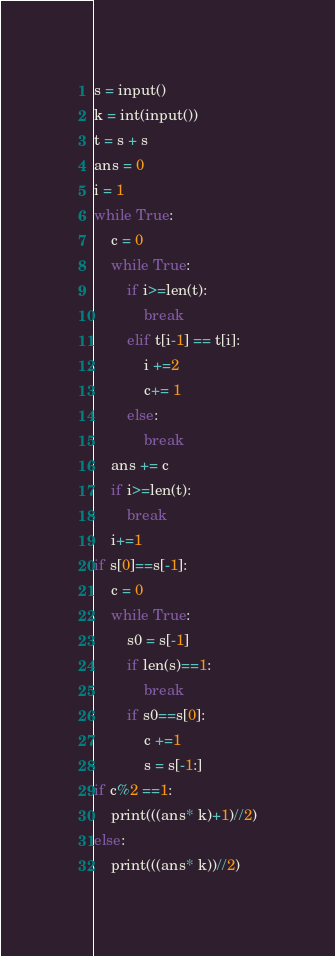<code> <loc_0><loc_0><loc_500><loc_500><_Python_>s = input()
k = int(input())
t = s + s
ans = 0
i = 1
while True:
    c = 0
    while True:
        if i>=len(t):
            break
        elif t[i-1] == t[i]:
            i +=2
            c+= 1
        else:
            break
    ans += c
    if i>=len(t):
        break
    i+=1
if s[0]==s[-1]:
    c = 0
    while True:
        s0 = s[-1]
        if len(s)==1:
            break
        if s0==s[0]:
            c +=1
            s = s[-1:]
if c%2 ==1:
    print(((ans* k)+1)//2)
else:
    print(((ans* k))//2)</code> 